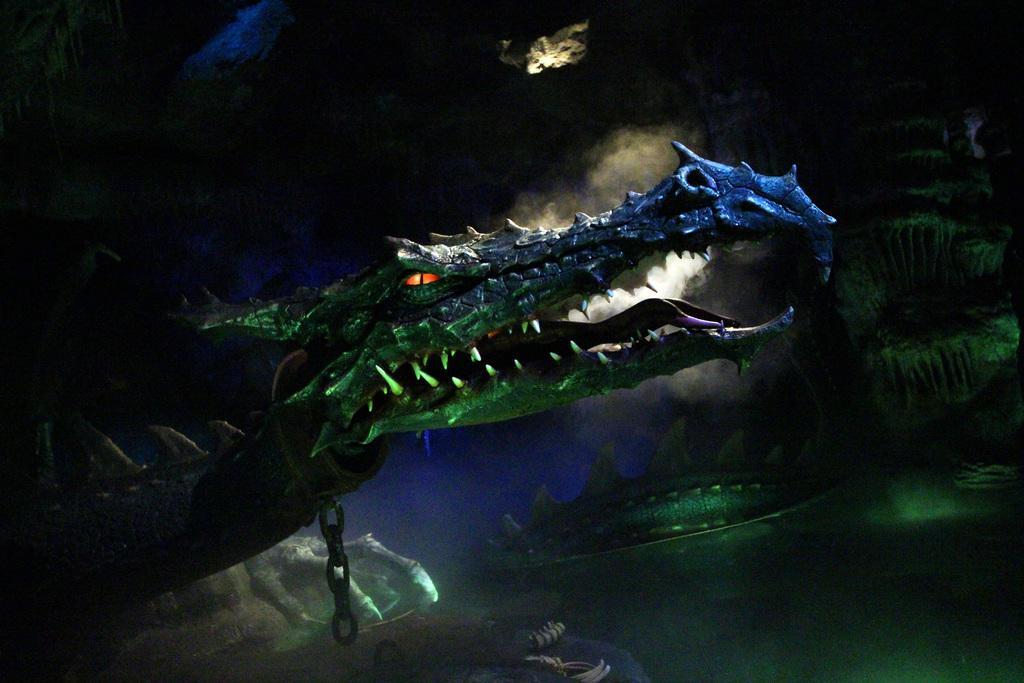How would you summarize this image in a sentence or two? This is an animated picture. Picture contains few animals. Left side there is an animal which is tied with the chain. 